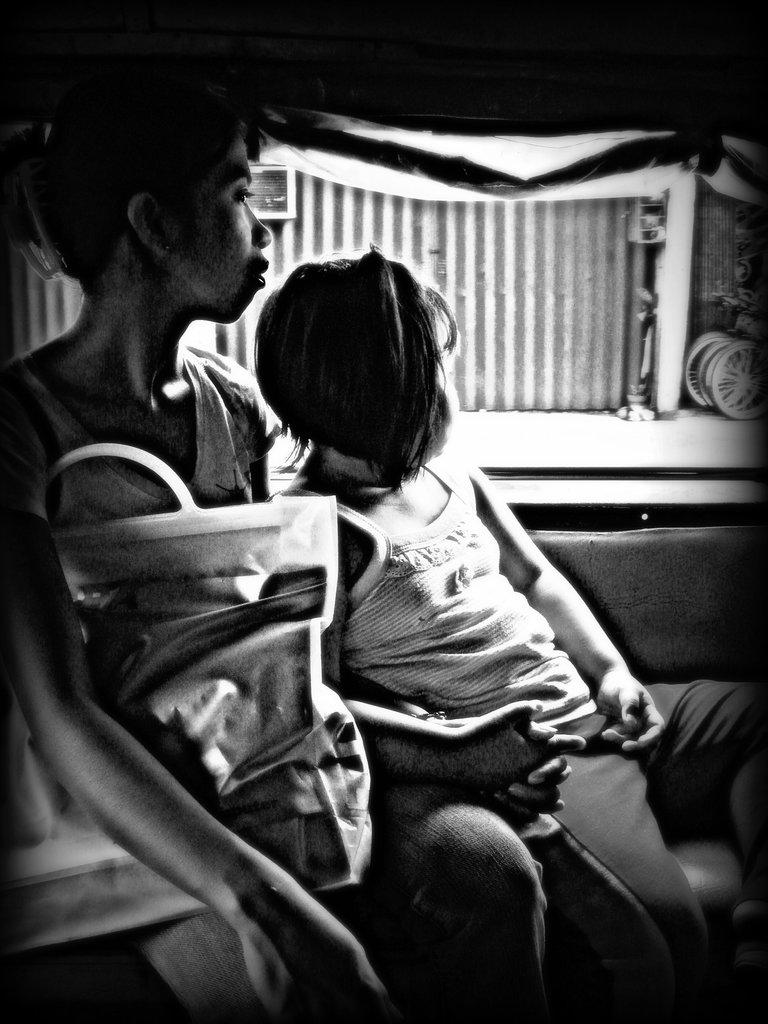What is the color scheme of the image? The image is black and white. How many people are in the image? There are two persons in the image. What else can be seen in the image besides the people? There are other objects in the image. What is visible in the background of the image? There is a fence and other objects visible in the background of the image. What is the tendency of the moon in the image? There is no moon present in the image. How does the image depict the people laughing? The image does not show the people laughing; it is in black and white, and their expressions cannot be determined. 